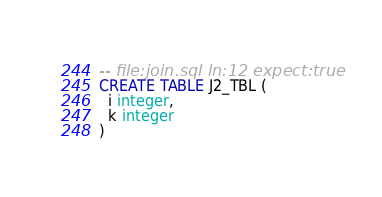Convert code to text. <code><loc_0><loc_0><loc_500><loc_500><_SQL_>-- file:join.sql ln:12 expect:true
CREATE TABLE J2_TBL (
  i integer,
  k integer
)
</code> 